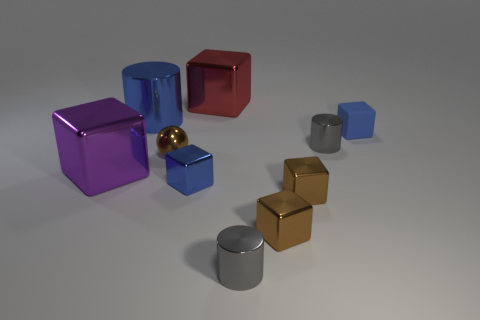There is a small matte block; is its color the same as the cylinder to the left of the shiny sphere?
Ensure brevity in your answer.  Yes. Is there anything else that is the same color as the ball?
Your answer should be very brief. Yes. There is another tiny thing that is the same color as the tiny rubber thing; what is its shape?
Your answer should be compact. Cube. What color is the tiny shiny cylinder in front of the large shiny object in front of the tiny metallic cylinder that is behind the small shiny sphere?
Ensure brevity in your answer.  Gray. Does the purple metal thing have the same size as the gray cylinder behind the big purple shiny block?
Your answer should be compact. No. What number of things are either small blue rubber cubes or large brown rubber things?
Keep it short and to the point. 1. Is there a blue cylinder that has the same material as the tiny sphere?
Make the answer very short. Yes. What size is the cube that is the same color as the matte thing?
Provide a short and direct response. Small. What color is the big metal block that is behind the small gray cylinder behind the big purple shiny cube?
Provide a short and direct response. Red. Is the blue cylinder the same size as the metallic ball?
Give a very brief answer. No. 